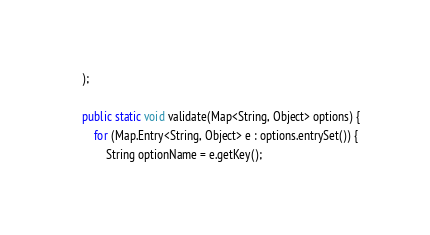Convert code to text. <code><loc_0><loc_0><loc_500><loc_500><_Java_>    );

    public static void validate(Map<String, Object> options) {
        for (Map.Entry<String, Object> e : options.entrySet()) {
            String optionName = e.getKey();</code> 